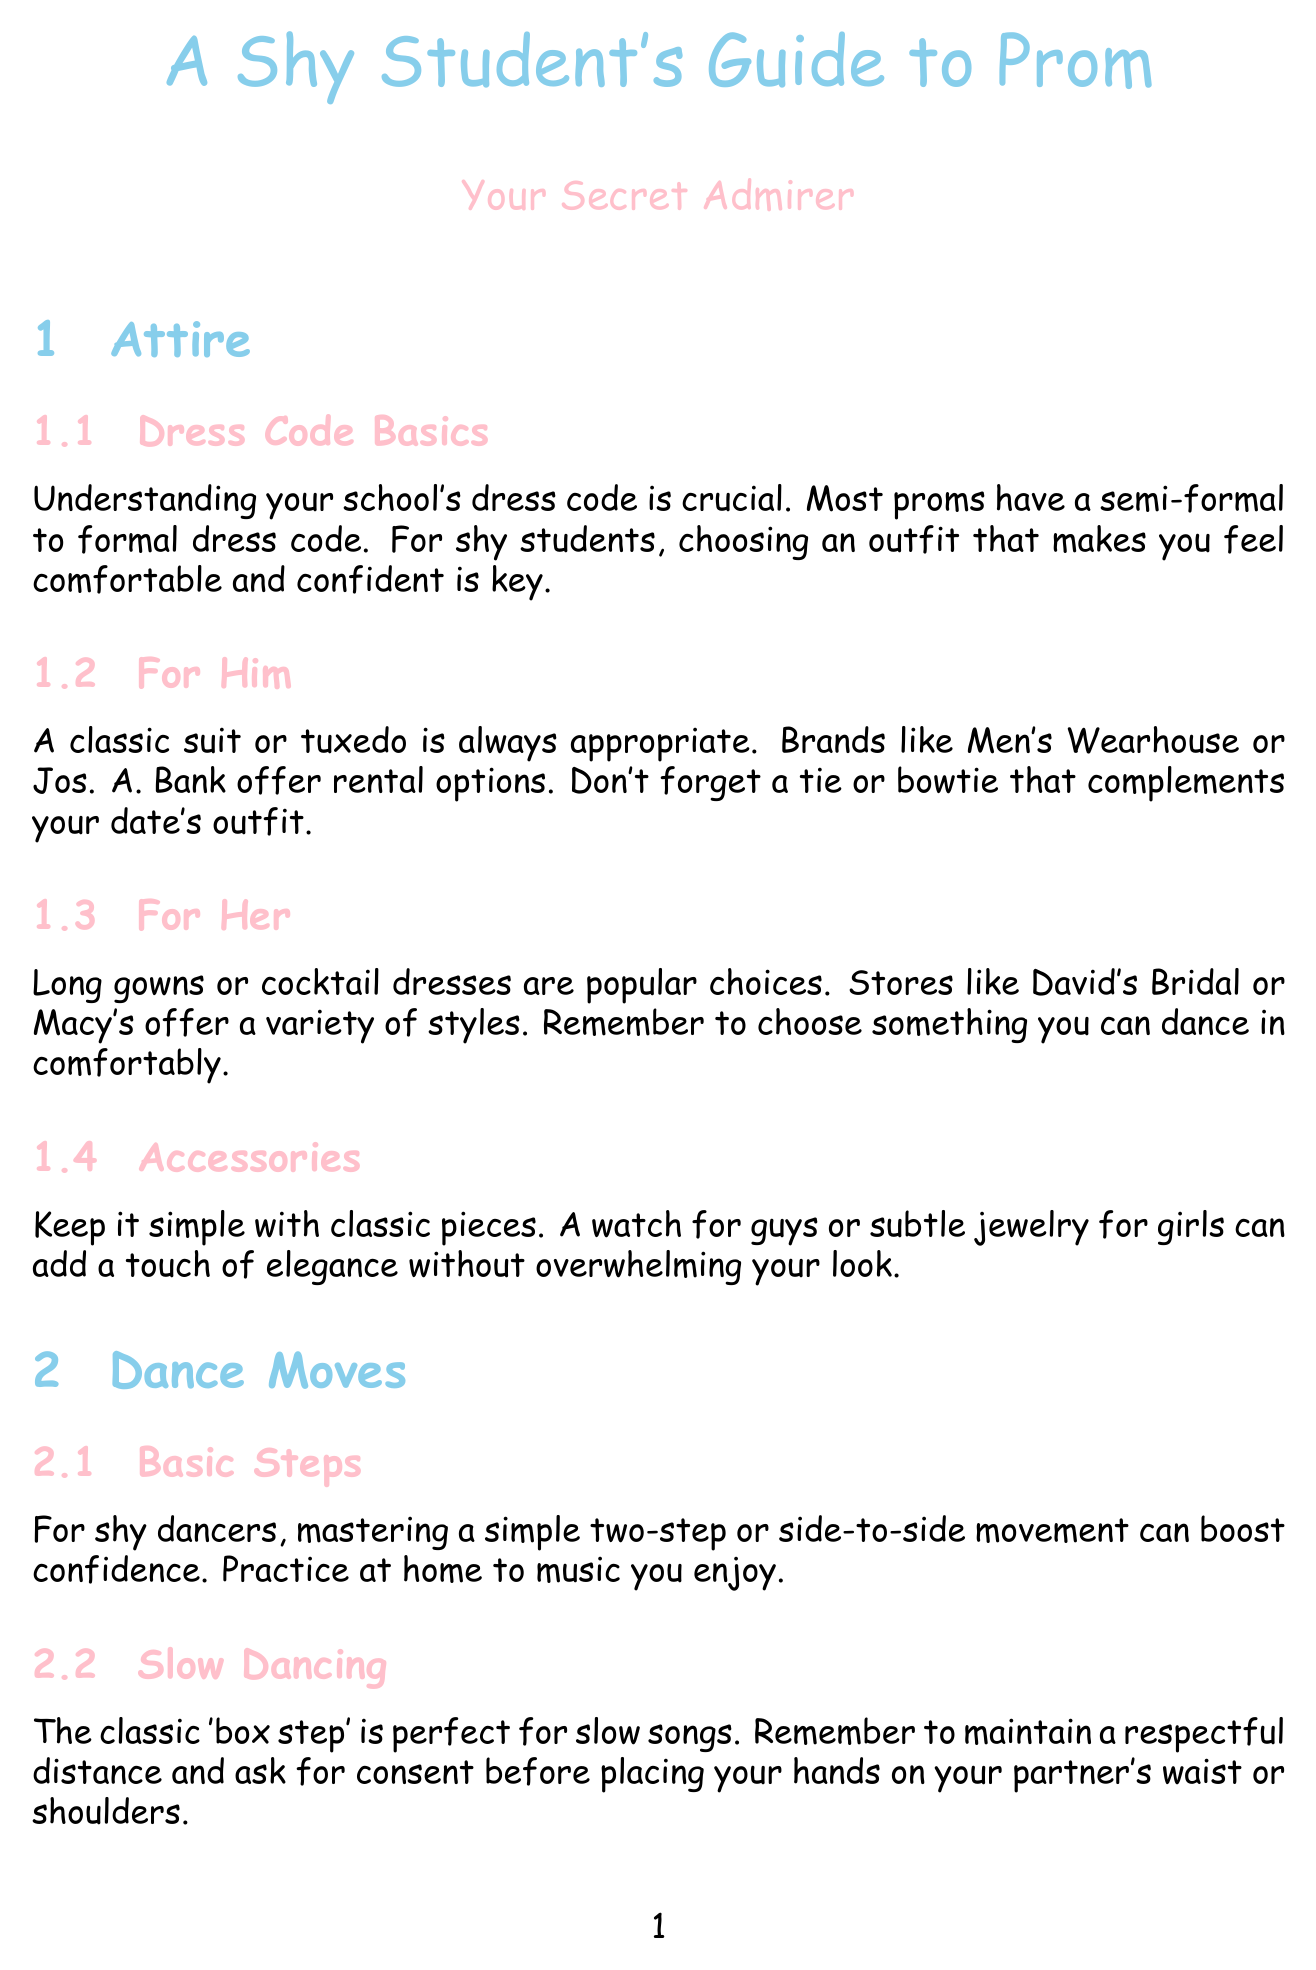what is the primary dress code for prom? The document states that most proms have a semi-formal to formal dress code.
Answer: semi-formal to formal what is a suitable outfit option for boys? The document recommends a classic suit or tuxedo for boys, highlighting rental options.
Answer: suit or tuxedo what is a recommended dance move for slow songs? According to the document, the classic 'box step' is perfect for slow songs.
Answer: box step what should you compliment your date about at the venue? The document suggests complimenting your date's outfit or commenting on decorations.
Answer: outfit or decorations what technique can help with anxiety at prom? The document mentions practicing deep breathing techniques as a way to alleviate anxiety.
Answer: breathing techniques how should you ask someone to prom according to the document? The document suggests asking, "Would you like to go to prom with me?" after establishing a common connection.
Answer: Would you like to go to prom with me? what should you remember when dining at prom? The document advises using proper table manners and starting with utensils from the outside.
Answer: proper table manners what is a key reminder for representing oneself when feeling nervous? The document emphasizes using positive self-talk and affirmations to manage anxiety.
Answer: positive self-talk 